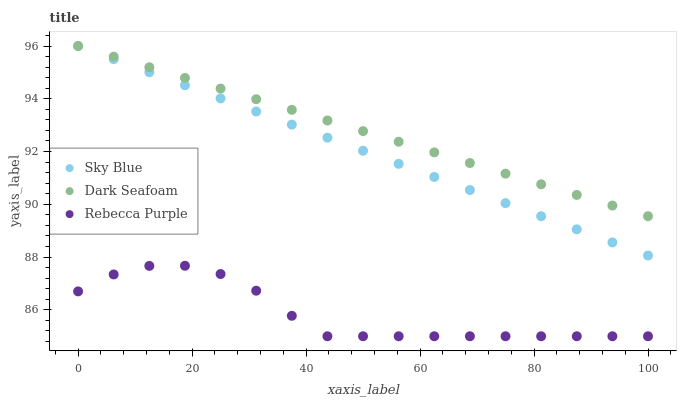Does Rebecca Purple have the minimum area under the curve?
Answer yes or no. Yes. Does Dark Seafoam have the maximum area under the curve?
Answer yes or no. Yes. Does Dark Seafoam have the minimum area under the curve?
Answer yes or no. No. Does Rebecca Purple have the maximum area under the curve?
Answer yes or no. No. Is Dark Seafoam the smoothest?
Answer yes or no. Yes. Is Rebecca Purple the roughest?
Answer yes or no. Yes. Is Rebecca Purple the smoothest?
Answer yes or no. No. Is Dark Seafoam the roughest?
Answer yes or no. No. Does Rebecca Purple have the lowest value?
Answer yes or no. Yes. Does Dark Seafoam have the lowest value?
Answer yes or no. No. Does Dark Seafoam have the highest value?
Answer yes or no. Yes. Does Rebecca Purple have the highest value?
Answer yes or no. No. Is Rebecca Purple less than Sky Blue?
Answer yes or no. Yes. Is Sky Blue greater than Rebecca Purple?
Answer yes or no. Yes. Does Sky Blue intersect Dark Seafoam?
Answer yes or no. Yes. Is Sky Blue less than Dark Seafoam?
Answer yes or no. No. Is Sky Blue greater than Dark Seafoam?
Answer yes or no. No. Does Rebecca Purple intersect Sky Blue?
Answer yes or no. No. 